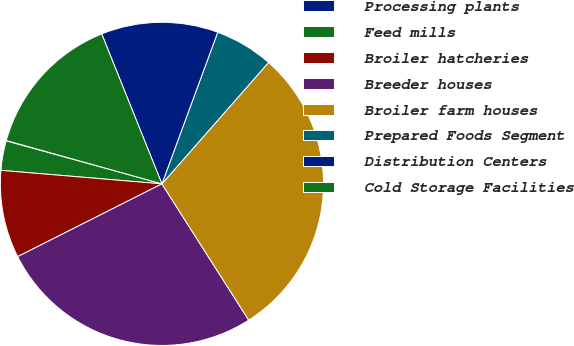<chart> <loc_0><loc_0><loc_500><loc_500><pie_chart><fcel>Processing plants<fcel>Feed mills<fcel>Broiler hatcheries<fcel>Breeder houses<fcel>Broiler farm houses<fcel>Prepared Foods Segment<fcel>Distribution Centers<fcel>Cold Storage Facilities<nl><fcel>0.04%<fcel>2.95%<fcel>8.77%<fcel>26.59%<fcel>29.5%<fcel>5.86%<fcel>11.69%<fcel>14.6%<nl></chart> 